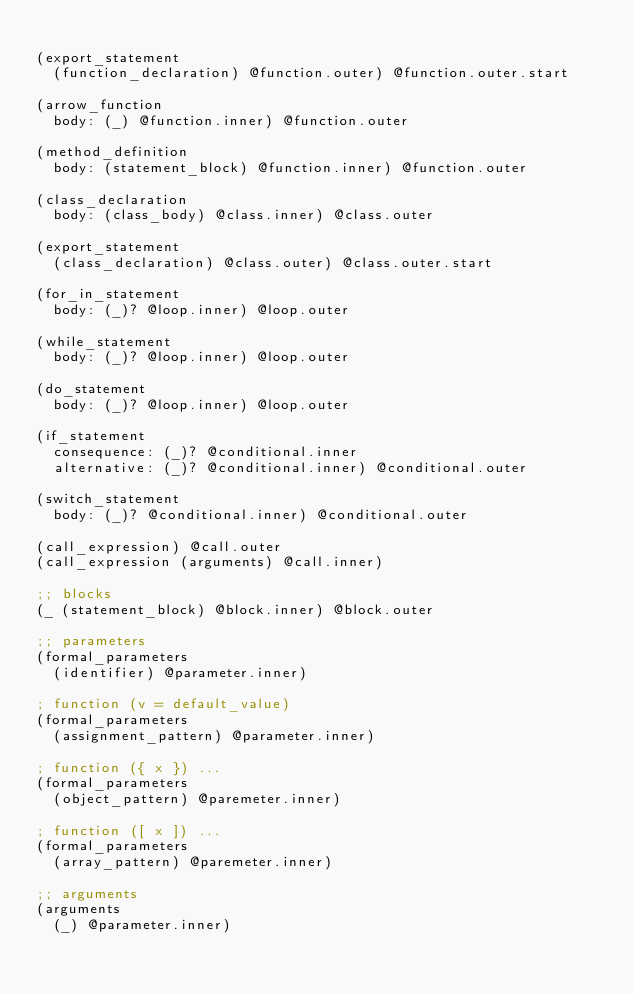<code> <loc_0><loc_0><loc_500><loc_500><_Scheme_>
(export_statement
  (function_declaration) @function.outer) @function.outer.start

(arrow_function
  body: (_) @function.inner) @function.outer

(method_definition
  body: (statement_block) @function.inner) @function.outer

(class_declaration
  body: (class_body) @class.inner) @class.outer

(export_statement
  (class_declaration) @class.outer) @class.outer.start

(for_in_statement
  body: (_)? @loop.inner) @loop.outer

(while_statement
  body: (_)? @loop.inner) @loop.outer

(do_statement
  body: (_)? @loop.inner) @loop.outer

(if_statement
  consequence: (_)? @conditional.inner
  alternative: (_)? @conditional.inner) @conditional.outer

(switch_statement
  body: (_)? @conditional.inner) @conditional.outer

(call_expression) @call.outer
(call_expression (arguments) @call.inner)

;; blocks
(_ (statement_block) @block.inner) @block.outer

;; parameters
(formal_parameters
  (identifier) @parameter.inner)

; function (v = default_value)
(formal_parameters
  (assignment_pattern) @parameter.inner)

; function ({ x }) ...
(formal_parameters
  (object_pattern) @paremeter.inner)

; function ([ x ]) ...
(formal_parameters
  (array_pattern) @paremeter.inner)

;; arguments
(arguments
  (_) @parameter.inner)
</code> 